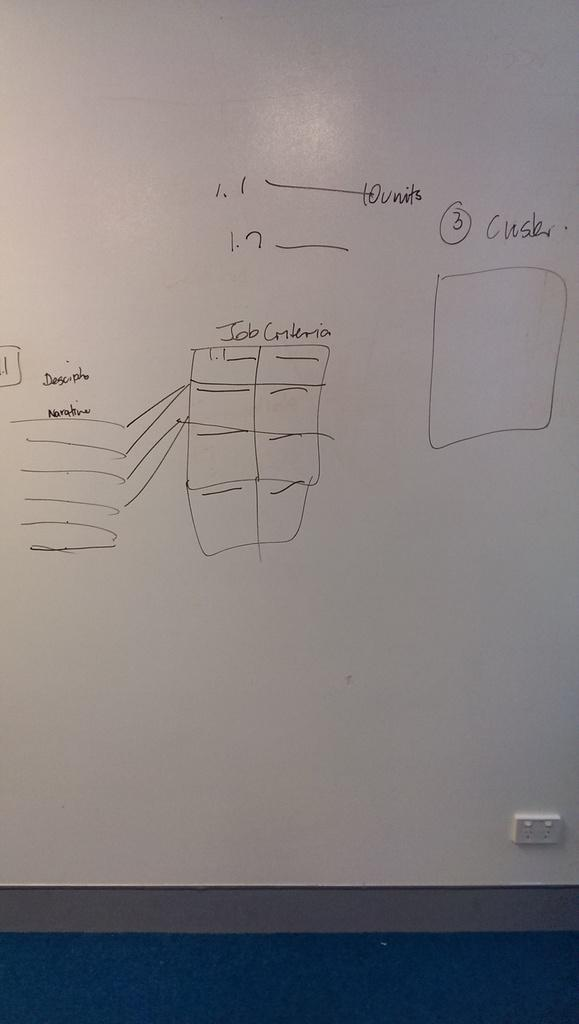<image>
Provide a brief description of the given image. A whiteboard has quick drawings and details about job criteria. 